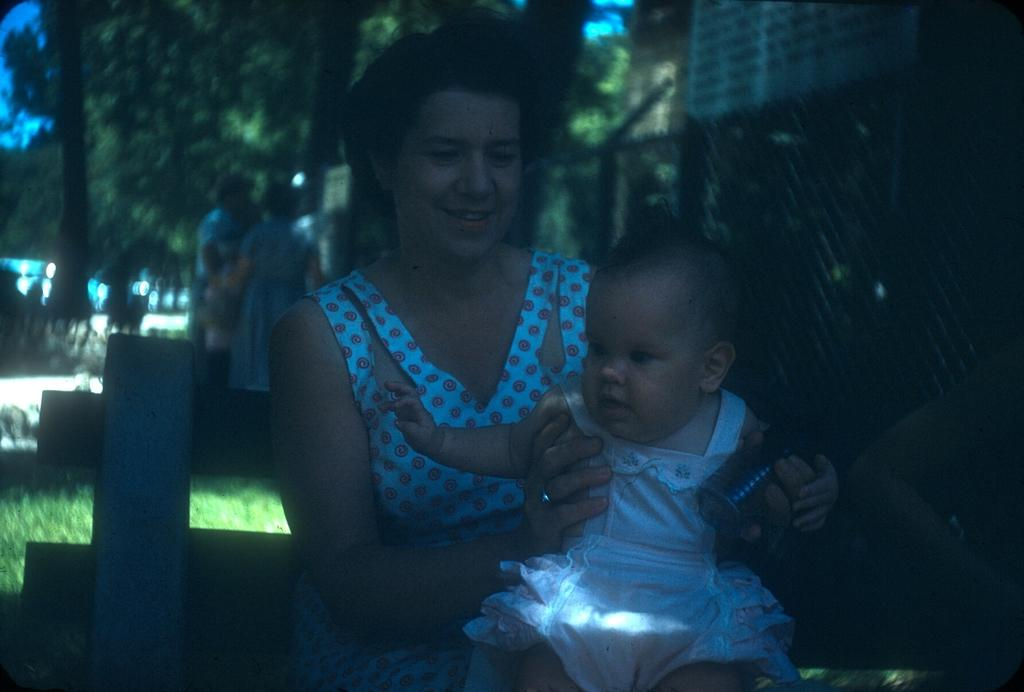Who or what can be seen in the image? There are people in the image. What type of natural environment is visible in the image? There is grass and trees in the image. What type of man-made structure is present in the image? There is a fence and buildings in the image. How would you describe the lighting in the image? The image is slightly dark. What time is indicated by the flag in the image? There is no flag present in the image, so it is not possible to determine the time indicated by a flag. 